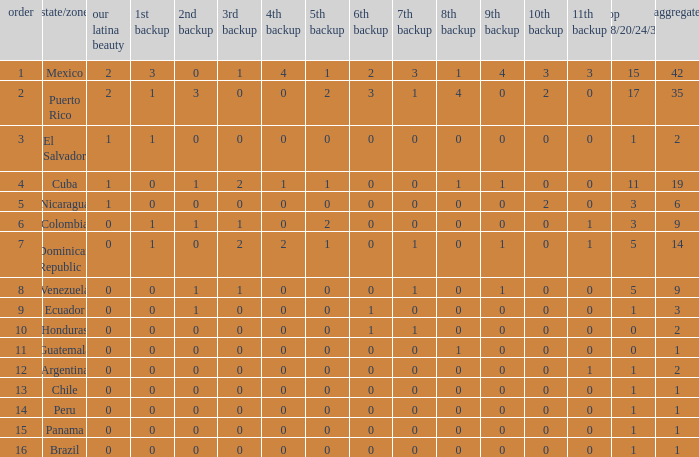What is the 7th runner-up of the country with a 10th runner-up greater than 0, a 9th runner-up greater than 0, and an 8th runner-up greater than 1? None. 